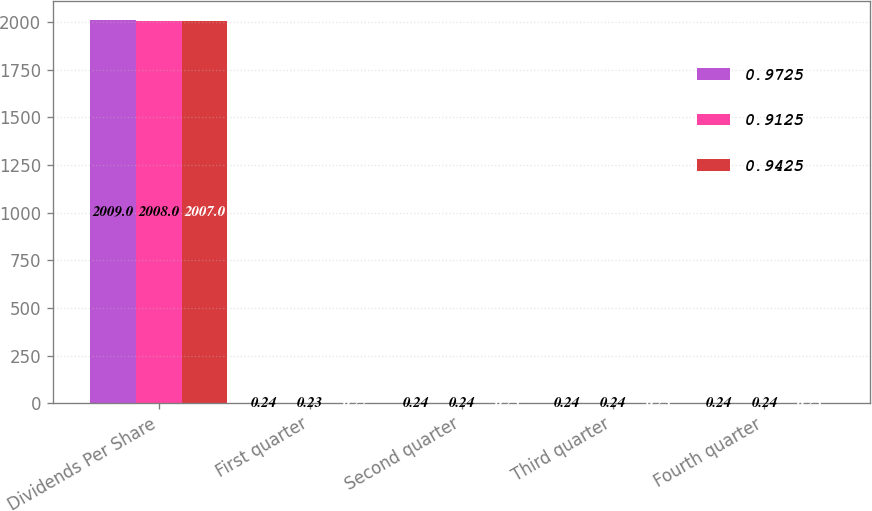<chart> <loc_0><loc_0><loc_500><loc_500><stacked_bar_chart><ecel><fcel>Dividends Per Share<fcel>First quarter<fcel>Second quarter<fcel>Third quarter<fcel>Fourth quarter<nl><fcel>0.9725<fcel>2009<fcel>0.24<fcel>0.24<fcel>0.24<fcel>0.24<nl><fcel>0.9125<fcel>2008<fcel>0.23<fcel>0.24<fcel>0.24<fcel>0.24<nl><fcel>0.9425<fcel>2007<fcel>0.22<fcel>0.23<fcel>0.23<fcel>0.23<nl></chart> 